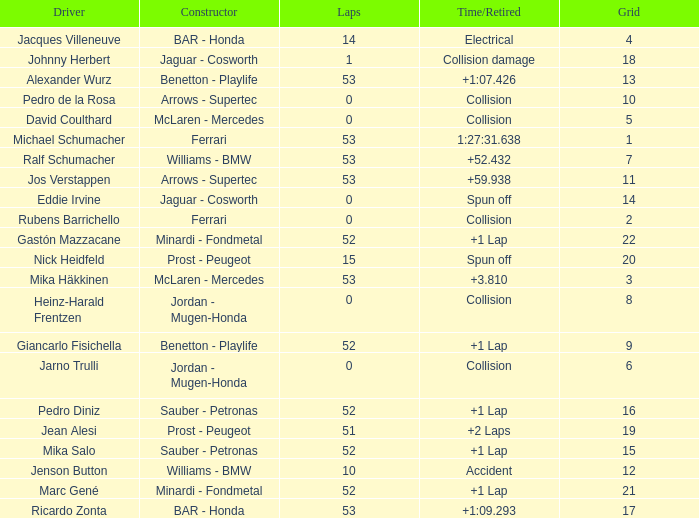How many laps did Ricardo Zonta have? 53.0. 